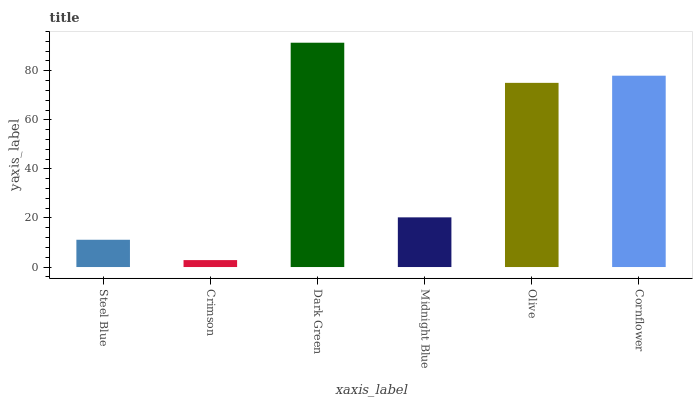Is Crimson the minimum?
Answer yes or no. Yes. Is Dark Green the maximum?
Answer yes or no. Yes. Is Dark Green the minimum?
Answer yes or no. No. Is Crimson the maximum?
Answer yes or no. No. Is Dark Green greater than Crimson?
Answer yes or no. Yes. Is Crimson less than Dark Green?
Answer yes or no. Yes. Is Crimson greater than Dark Green?
Answer yes or no. No. Is Dark Green less than Crimson?
Answer yes or no. No. Is Olive the high median?
Answer yes or no. Yes. Is Midnight Blue the low median?
Answer yes or no. Yes. Is Cornflower the high median?
Answer yes or no. No. Is Cornflower the low median?
Answer yes or no. No. 